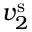<formula> <loc_0><loc_0><loc_500><loc_500>v _ { 2 } ^ { s }</formula> 